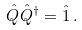Convert formula to latex. <formula><loc_0><loc_0><loc_500><loc_500>\hat { Q } \hat { Q } ^ { \dagger } = \hat { 1 } \, .</formula> 